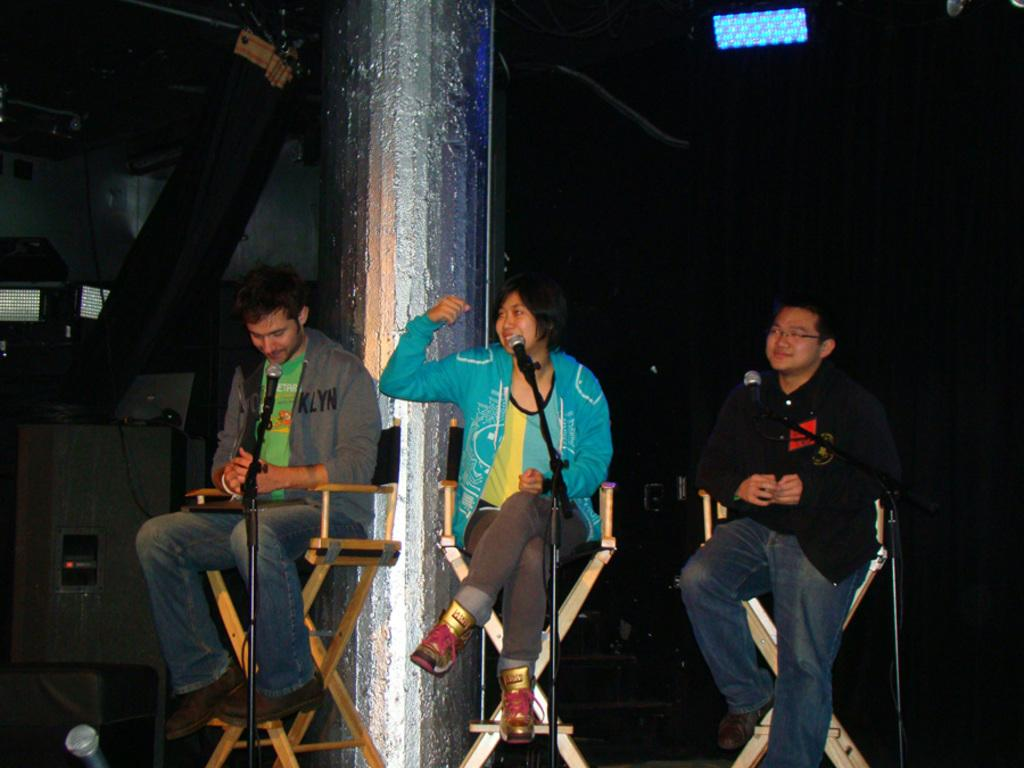How many people are in the image? There are three people in the image. What are the people doing in the image? The people are sitting on chairs. What objects are in front of the people? There are microphones in front of the people. What can be seen behind the people? There is a pillar behind the people. How would you describe the background of the pillar? The background of the pillar is dark. How many beds can be seen in the image? There are no beds present in the image. What type of loss is depicted in the image? There is no loss depicted in the image; it features three people sitting on chairs with microphones in front of them. 